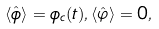Convert formula to latex. <formula><loc_0><loc_0><loc_500><loc_500>\langle \hat { \phi } \rangle = \phi _ { c } ( t ) , \langle \hat { \varphi } \rangle = 0 ,</formula> 